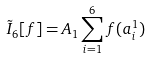Convert formula to latex. <formula><loc_0><loc_0><loc_500><loc_500>\tilde { I } _ { 6 } [ f ] = A _ { 1 } \sum _ { i = 1 } ^ { 6 } f ( a _ { i } ^ { 1 } )</formula> 